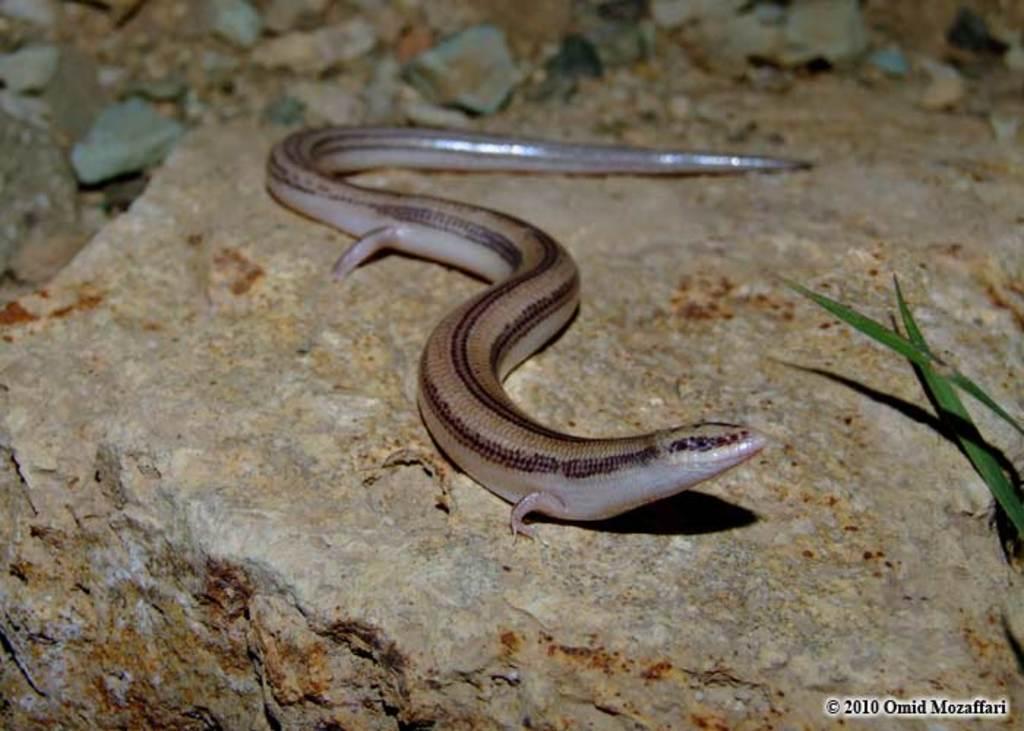Describe this image in one or two sentences. In this image there is a snake, there are stones and there are leaves and there is some text and numbers written on the image. 